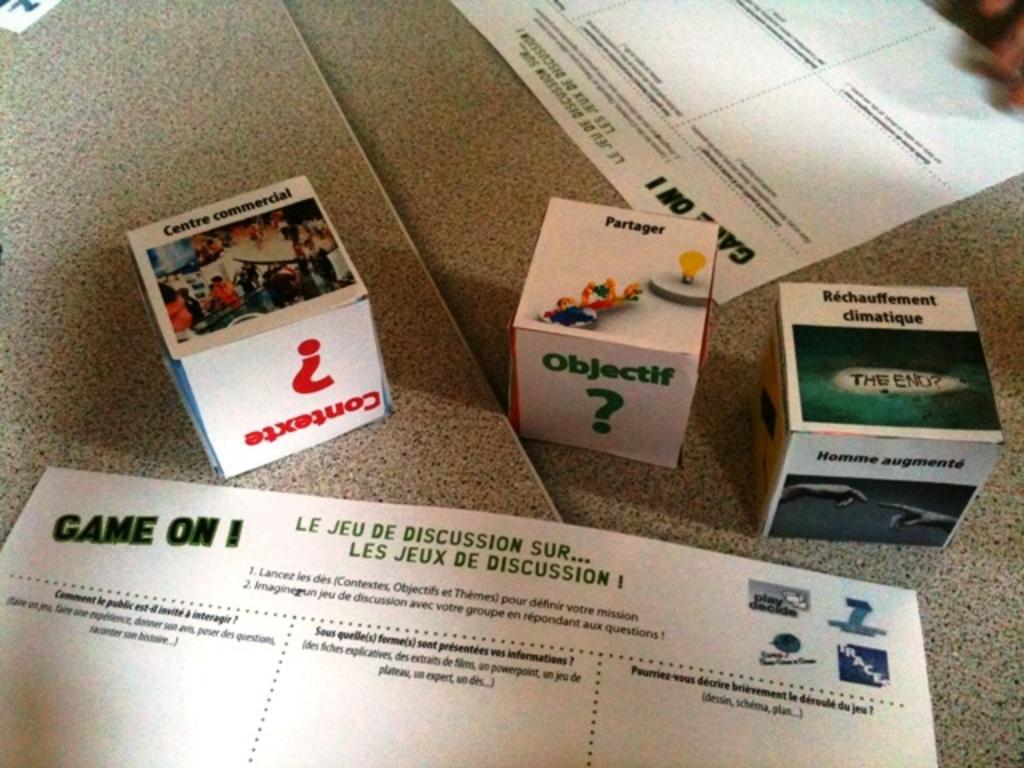How would you summarize this image in a sentence or two? In this picture we can see few boxes and papers on the ground. 